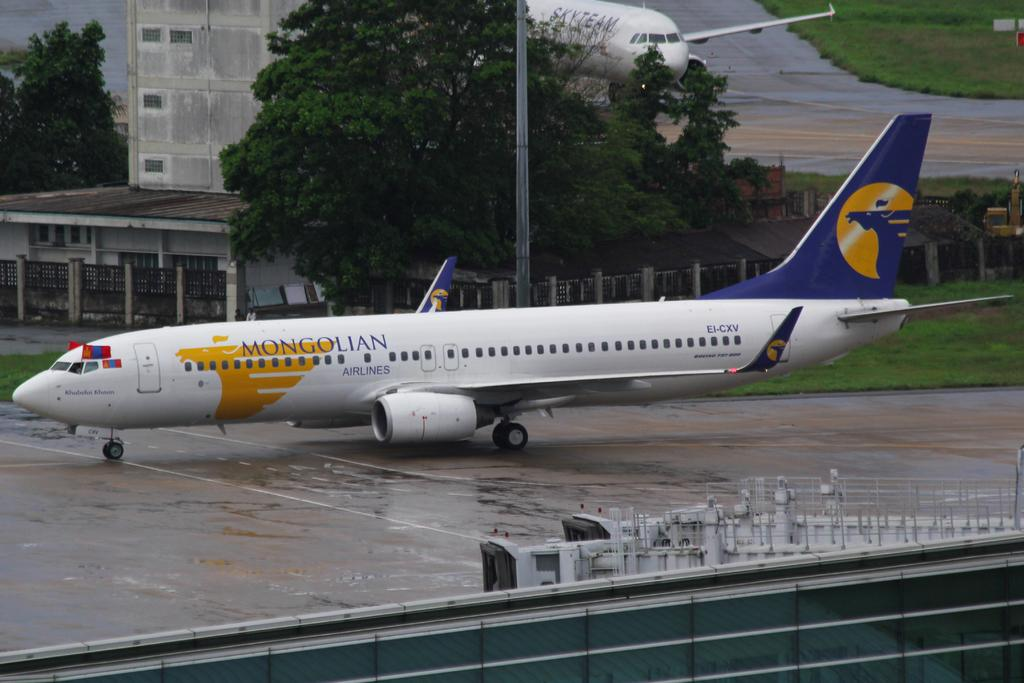<image>
Give a short and clear explanation of the subsequent image. A Mongolian airplane is on a wet runway. 